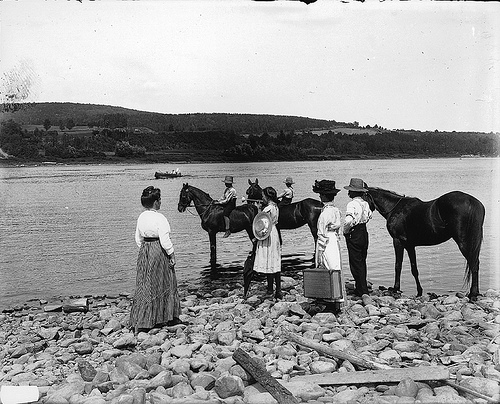What might be the reason for these people gathering by the river with horses? The group is likely gathered at the river for a purpose related to transportation or travel, such as crossing the river to reach a destination on the other side. Rivers often served as natural barriers that required coordination and effort to cross, especially before the widespread availability of bridges in rural locales. 